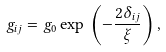<formula> <loc_0><loc_0><loc_500><loc_500>g _ { i j } = g _ { 0 } \exp \, \left ( - \frac { 2 \delta _ { i j } } { \xi } \right ) ,</formula> 